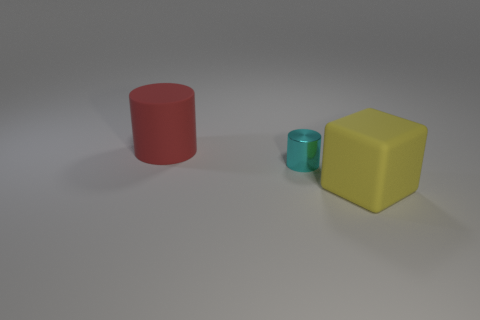Is the material of the big red object the same as the large thing that is right of the matte cylinder?
Keep it short and to the point. Yes. What is the shape of the object that is to the right of the big red cylinder and on the left side of the yellow matte thing?
Provide a succinct answer. Cylinder. How many other objects are there of the same color as the tiny shiny thing?
Provide a succinct answer. 0. What is the shape of the cyan metallic object?
Your answer should be compact. Cylinder. There is a big matte object right of the rubber cylinder that is behind the block; what is its color?
Make the answer very short. Yellow. There is a thing that is left of the yellow cube and in front of the large red thing; what is it made of?
Your answer should be compact. Metal. Is there a cyan metallic block of the same size as the red thing?
Make the answer very short. No. There is a red cylinder that is the same size as the yellow object; what material is it?
Your response must be concise. Rubber. There is a large yellow matte cube; how many tiny metallic cylinders are in front of it?
Give a very brief answer. 0. Is the shape of the object that is on the right side of the cyan metallic object the same as  the large red rubber thing?
Your answer should be very brief. No. 